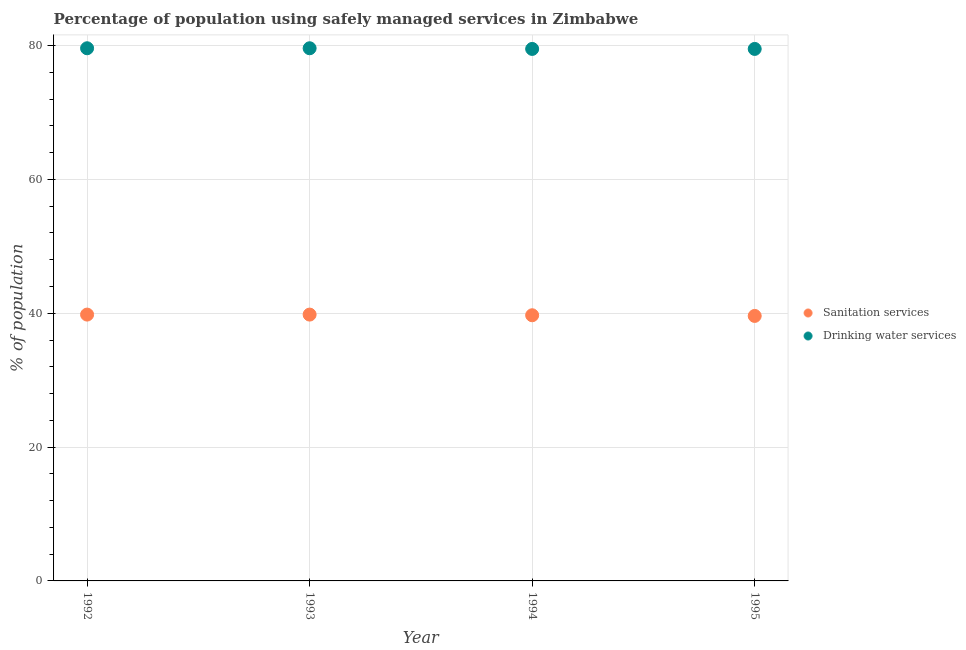Is the number of dotlines equal to the number of legend labels?
Provide a short and direct response. Yes. What is the percentage of population who used sanitation services in 1995?
Your answer should be very brief. 39.6. Across all years, what is the maximum percentage of population who used drinking water services?
Offer a very short reply. 79.6. Across all years, what is the minimum percentage of population who used drinking water services?
Make the answer very short. 79.5. In which year was the percentage of population who used sanitation services maximum?
Make the answer very short. 1992. In which year was the percentage of population who used drinking water services minimum?
Your response must be concise. 1994. What is the total percentage of population who used drinking water services in the graph?
Your answer should be very brief. 318.2. What is the difference between the percentage of population who used sanitation services in 1994 and that in 1995?
Give a very brief answer. 0.1. What is the difference between the percentage of population who used drinking water services in 1994 and the percentage of population who used sanitation services in 1992?
Your answer should be compact. 39.7. What is the average percentage of population who used drinking water services per year?
Make the answer very short. 79.55. In the year 1995, what is the difference between the percentage of population who used sanitation services and percentage of population who used drinking water services?
Ensure brevity in your answer.  -39.9. What is the ratio of the percentage of population who used drinking water services in 1992 to that in 1994?
Provide a short and direct response. 1. Is the percentage of population who used drinking water services in 1993 less than that in 1995?
Your answer should be very brief. No. What is the difference between the highest and the second highest percentage of population who used sanitation services?
Give a very brief answer. 0. What is the difference between the highest and the lowest percentage of population who used drinking water services?
Give a very brief answer. 0.1. In how many years, is the percentage of population who used sanitation services greater than the average percentage of population who used sanitation services taken over all years?
Make the answer very short. 2. Is the sum of the percentage of population who used sanitation services in 1992 and 1994 greater than the maximum percentage of population who used drinking water services across all years?
Provide a succinct answer. No. What is the difference between two consecutive major ticks on the Y-axis?
Offer a terse response. 20. Are the values on the major ticks of Y-axis written in scientific E-notation?
Ensure brevity in your answer.  No. Does the graph contain any zero values?
Offer a terse response. No. How many legend labels are there?
Your response must be concise. 2. What is the title of the graph?
Your answer should be very brief. Percentage of population using safely managed services in Zimbabwe. Does "Old" appear as one of the legend labels in the graph?
Give a very brief answer. No. What is the label or title of the Y-axis?
Your answer should be compact. % of population. What is the % of population in Sanitation services in 1992?
Your answer should be very brief. 39.8. What is the % of population in Drinking water services in 1992?
Your answer should be compact. 79.6. What is the % of population in Sanitation services in 1993?
Keep it short and to the point. 39.8. What is the % of population in Drinking water services in 1993?
Your response must be concise. 79.6. What is the % of population of Sanitation services in 1994?
Your response must be concise. 39.7. What is the % of population of Drinking water services in 1994?
Keep it short and to the point. 79.5. What is the % of population in Sanitation services in 1995?
Make the answer very short. 39.6. What is the % of population of Drinking water services in 1995?
Your response must be concise. 79.5. Across all years, what is the maximum % of population of Sanitation services?
Make the answer very short. 39.8. Across all years, what is the maximum % of population of Drinking water services?
Make the answer very short. 79.6. Across all years, what is the minimum % of population of Sanitation services?
Your response must be concise. 39.6. Across all years, what is the minimum % of population in Drinking water services?
Your answer should be very brief. 79.5. What is the total % of population of Sanitation services in the graph?
Provide a short and direct response. 158.9. What is the total % of population of Drinking water services in the graph?
Provide a succinct answer. 318.2. What is the difference between the % of population of Sanitation services in 1992 and that in 1995?
Your answer should be very brief. 0.2. What is the difference between the % of population in Drinking water services in 1993 and that in 1994?
Make the answer very short. 0.1. What is the difference between the % of population in Sanitation services in 1994 and that in 1995?
Make the answer very short. 0.1. What is the difference between the % of population in Sanitation services in 1992 and the % of population in Drinking water services in 1993?
Keep it short and to the point. -39.8. What is the difference between the % of population of Sanitation services in 1992 and the % of population of Drinking water services in 1994?
Offer a terse response. -39.7. What is the difference between the % of population of Sanitation services in 1992 and the % of population of Drinking water services in 1995?
Provide a succinct answer. -39.7. What is the difference between the % of population of Sanitation services in 1993 and the % of population of Drinking water services in 1994?
Keep it short and to the point. -39.7. What is the difference between the % of population of Sanitation services in 1993 and the % of population of Drinking water services in 1995?
Offer a very short reply. -39.7. What is the difference between the % of population in Sanitation services in 1994 and the % of population in Drinking water services in 1995?
Your answer should be compact. -39.8. What is the average % of population of Sanitation services per year?
Ensure brevity in your answer.  39.73. What is the average % of population in Drinking water services per year?
Give a very brief answer. 79.55. In the year 1992, what is the difference between the % of population in Sanitation services and % of population in Drinking water services?
Provide a short and direct response. -39.8. In the year 1993, what is the difference between the % of population of Sanitation services and % of population of Drinking water services?
Give a very brief answer. -39.8. In the year 1994, what is the difference between the % of population of Sanitation services and % of population of Drinking water services?
Provide a succinct answer. -39.8. In the year 1995, what is the difference between the % of population of Sanitation services and % of population of Drinking water services?
Your answer should be compact. -39.9. What is the ratio of the % of population of Drinking water services in 1992 to that in 1994?
Offer a very short reply. 1. What is the ratio of the % of population in Drinking water services in 1993 to that in 1994?
Offer a terse response. 1. What is the ratio of the % of population of Sanitation services in 1994 to that in 1995?
Your answer should be compact. 1. What is the difference between the highest and the second highest % of population of Sanitation services?
Ensure brevity in your answer.  0. What is the difference between the highest and the lowest % of population of Drinking water services?
Provide a short and direct response. 0.1. 